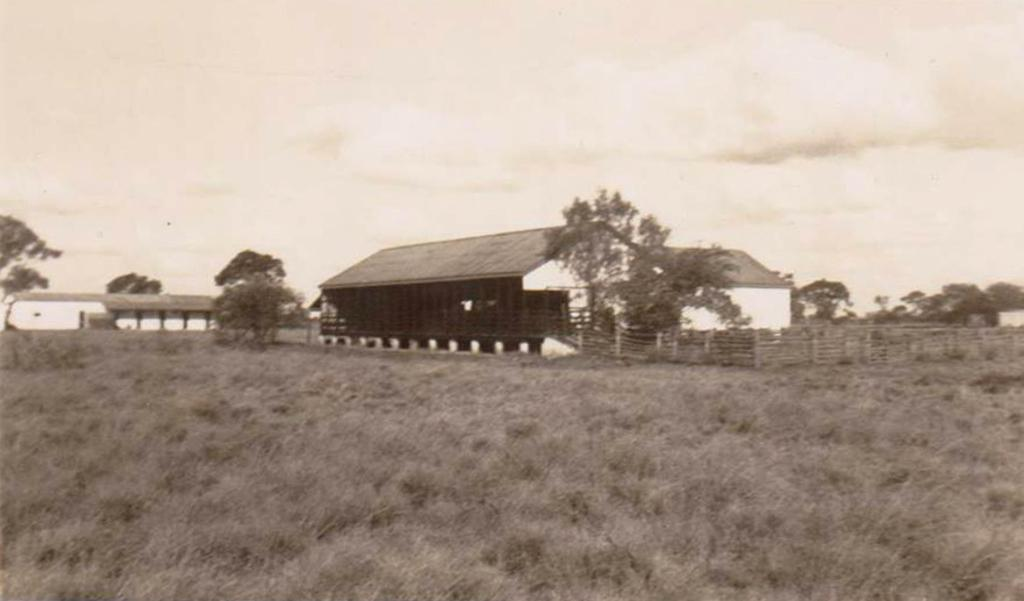What is the color scheme of the image? The image is black and white. What type of vegetation is in the foreground of the image? There is grass in the foreground of the image. What structures can be seen in the middle of the image? There are houses and trees in the middle of the image. What is visible at the top of the image? The sky is visible at the top of the image. Can you see a snake slithering through the grass in the image? There is no snake present in the image; it only features grass, houses, trees, and the sky. What invention is being used by the trees in the image? There is no invention associated with the trees in the image; they are simply trees in a natural setting. 